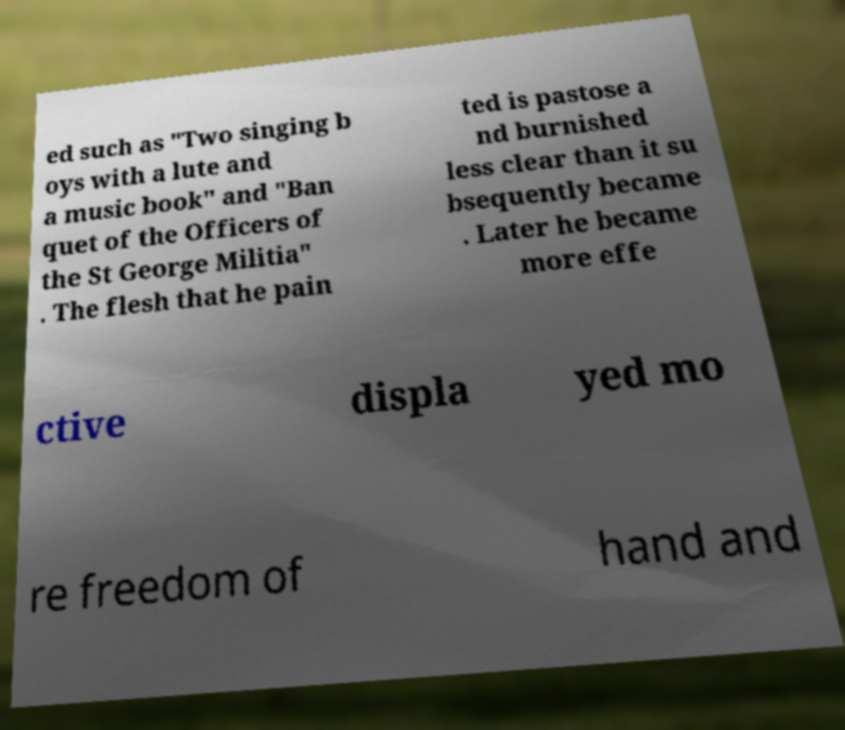Please read and relay the text visible in this image. What does it say? ed such as "Two singing b oys with a lute and a music book" and "Ban quet of the Officers of the St George Militia" . The flesh that he pain ted is pastose a nd burnished less clear than it su bsequently became . Later he became more effe ctive displa yed mo re freedom of hand and 